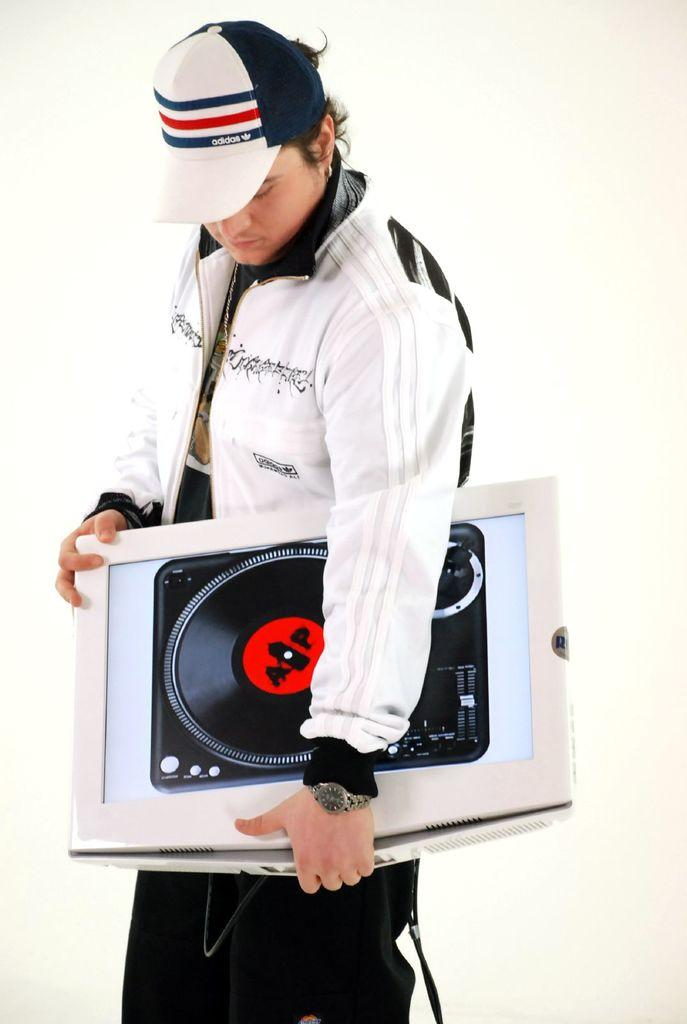What is the person in the image wearing? The person is wearing a white jacket and black pants. What type of headwear is the person wearing? The person is wearing a white cap. What color is the cap? The cap is white. What is the person holding in their hands? The person is holding an object in their hands. What type of horn can be seen on the person's head in the image? There is no horn present on the person's head in the image. How many visitors are visible in the image? The image only features one person, so there are no visitors visible. 